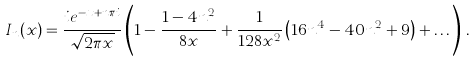Convert formula to latex. <formula><loc_0><loc_0><loc_500><loc_500>I _ { n } ( x ) = \frac { i e ^ { - x + n \pi i } } { \sqrt { 2 \pi x } } \left ( 1 - \frac { 1 - 4 n ^ { 2 } } { 8 x } + \frac { 1 } { 1 2 8 x ^ { 2 } } \left ( 1 6 n ^ { 4 } - 4 0 n ^ { 2 } + 9 \right ) + \dots \right ) \, .</formula> 